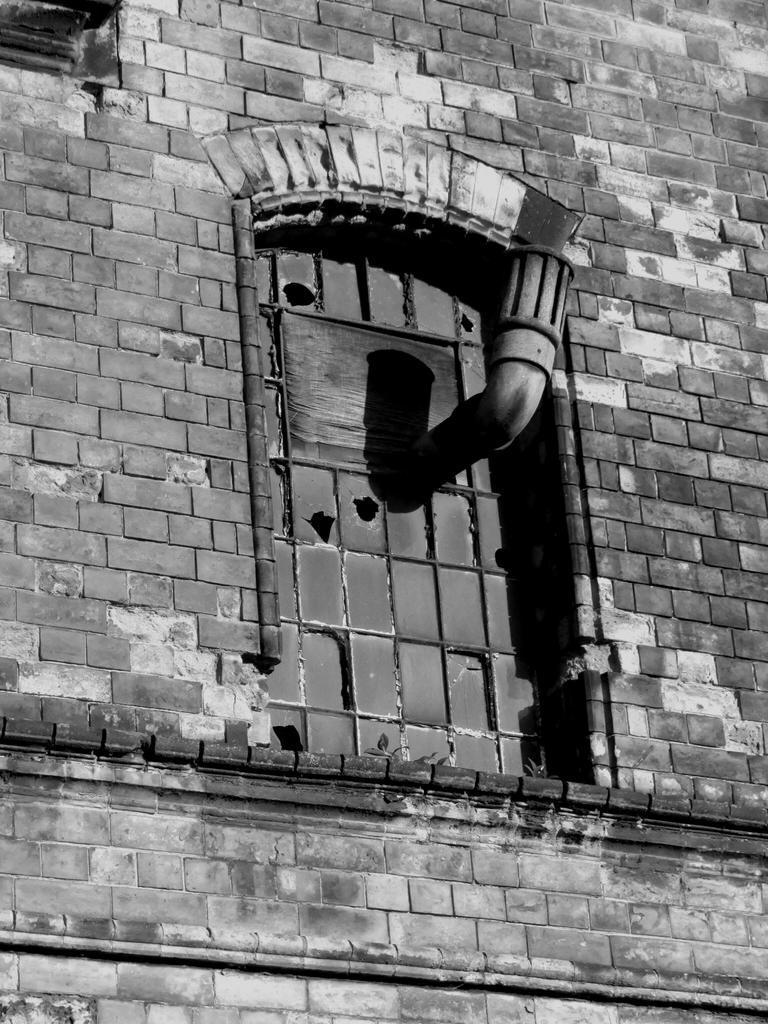Could you give a brief overview of what you see in this image? In the given image i can see a brick work. 